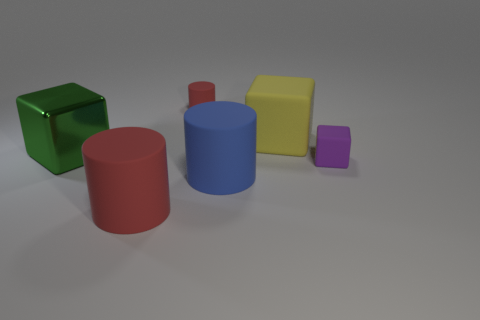How many large blue balls are there?
Give a very brief answer. 0. Is the red thing that is in front of the shiny block made of the same material as the large green object?
Keep it short and to the point. No. Are there any yellow metal objects of the same size as the blue thing?
Your answer should be very brief. No. Do the small purple rubber object and the big object behind the metal thing have the same shape?
Ensure brevity in your answer.  Yes. There is a large blue rubber cylinder in front of the small rubber thing in front of the large rubber block; is there a large matte object in front of it?
Provide a short and direct response. Yes. How big is the blue thing?
Your answer should be compact. Large. How many other things are there of the same color as the tiny block?
Give a very brief answer. 0. Do the red matte object that is in front of the tiny red cylinder and the tiny red object have the same shape?
Your answer should be compact. Yes. What color is the other tiny object that is the same shape as the yellow rubber object?
Offer a very short reply. Purple. Are there any other things that have the same material as the large green object?
Offer a very short reply. No. 